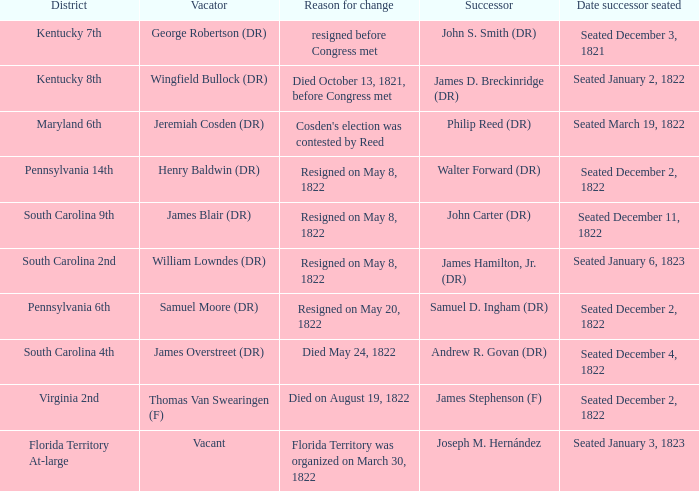Who is the vacator when south carolina 4th is the district? James Overstreet (DR). 